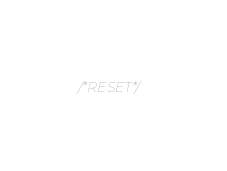<code> <loc_0><loc_0><loc_500><loc_500><_CSS_>/*RESET*/</code> 